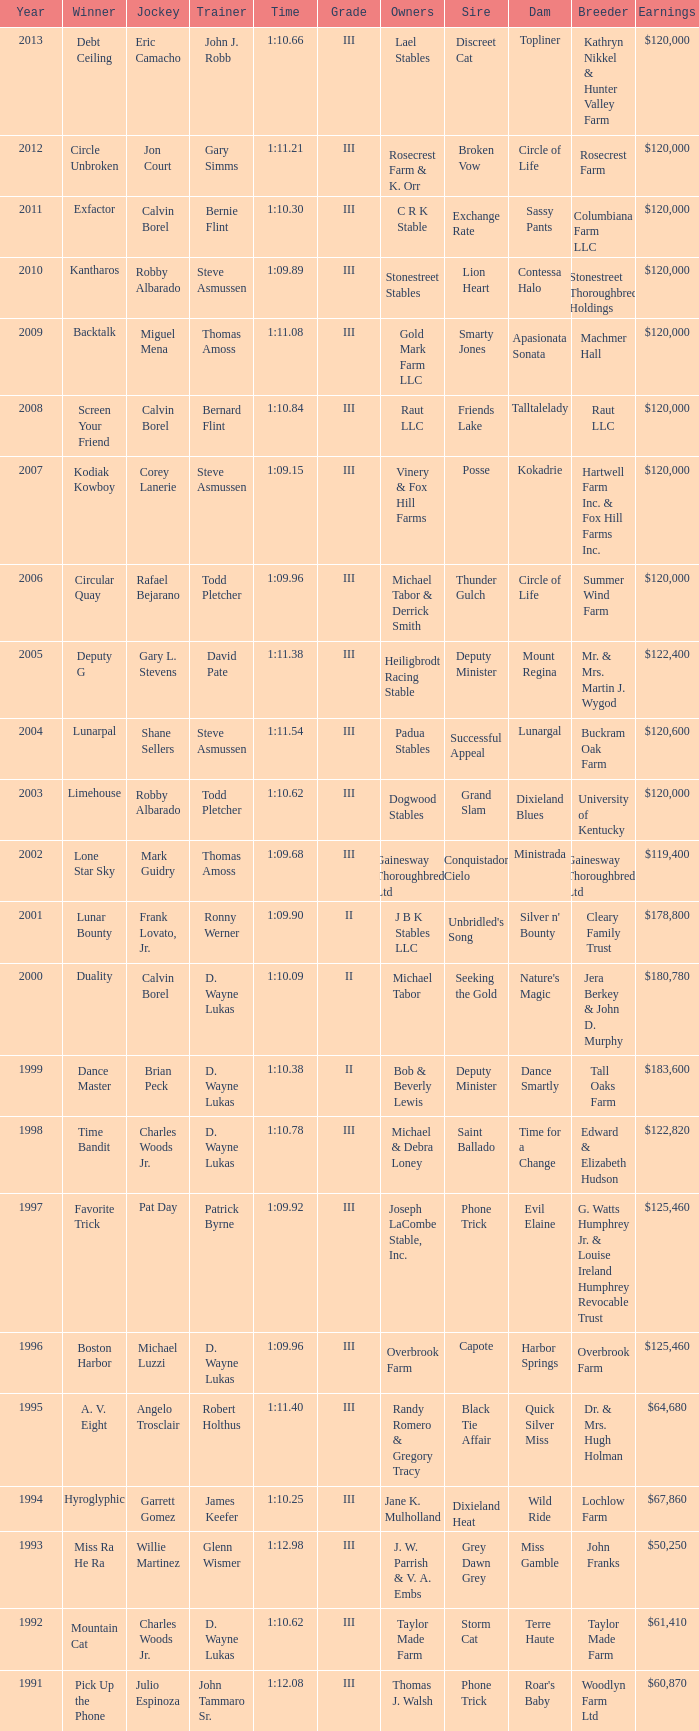Which trainer won the hyroglyphic in a year that was before 2010? James Keefer. Give me the full table as a dictionary. {'header': ['Year', 'Winner', 'Jockey', 'Trainer', 'Time', 'Grade', 'Owners', 'Sire', 'Dam', 'Breeder', 'Earnings'], 'rows': [['2013', 'Debt Ceiling', 'Eric Camacho', 'John J. Robb', '1:10.66', 'III', 'Lael Stables', 'Discreet Cat', 'Topliner', 'Kathryn Nikkel & Hunter Valley Farm', '$120,000'], ['2012', 'Circle Unbroken', 'Jon Court', 'Gary Simms', '1:11.21', 'III', 'Rosecrest Farm & K. Orr', 'Broken Vow', 'Circle of Life', 'Rosecrest Farm', '$120,000'], ['2011', 'Exfactor', 'Calvin Borel', 'Bernie Flint', '1:10.30', 'III', 'C R K Stable', 'Exchange Rate', 'Sassy Pants', 'Columbiana Farm LLC', '$120,000'], ['2010', 'Kantharos', 'Robby Albarado', 'Steve Asmussen', '1:09.89', 'III', 'Stonestreet Stables', 'Lion Heart', 'Contessa Halo', 'Stonestreet Thoroughbred Holdings', '$120,000'], ['2009', 'Backtalk', 'Miguel Mena', 'Thomas Amoss', '1:11.08', 'III', 'Gold Mark Farm LLC', 'Smarty Jones', 'Apasionata Sonata', 'Machmer Hall', '$120,000'], ['2008', 'Screen Your Friend', 'Calvin Borel', 'Bernard Flint', '1:10.84', 'III', 'Raut LLC', 'Friends Lake', 'Talltalelady', 'Raut LLC', '$120,000'], ['2007', 'Kodiak Kowboy', 'Corey Lanerie', 'Steve Asmussen', '1:09.15', 'III', 'Vinery & Fox Hill Farms', 'Posse', 'Kokadrie', 'Hartwell Farm Inc. & Fox Hill Farms Inc.', '$120,000'], ['2006', 'Circular Quay', 'Rafael Bejarano', 'Todd Pletcher', '1:09.96', 'III', 'Michael Tabor & Derrick Smith', 'Thunder Gulch', 'Circle of Life', 'Summer Wind Farm', '$120,000'], ['2005', 'Deputy G', 'Gary L. Stevens', 'David Pate', '1:11.38', 'III', 'Heiligbrodt Racing Stable', 'Deputy Minister', 'Mount Regina', 'Mr. & Mrs. Martin J. Wygod', '$122,400'], ['2004', 'Lunarpal', 'Shane Sellers', 'Steve Asmussen', '1:11.54', 'III', 'Padua Stables', 'Successful Appeal', 'Lunargal', 'Buckram Oak Farm', '$120,600'], ['2003', 'Limehouse', 'Robby Albarado', 'Todd Pletcher', '1:10.62', 'III', 'Dogwood Stables', 'Grand Slam', 'Dixieland Blues', 'University of Kentucky', '$120,000'], ['2002', 'Lone Star Sky', 'Mark Guidry', 'Thomas Amoss', '1:09.68', 'III', 'Gainesway Thoroughbreds Ltd', 'Conquistador Cielo', 'Ministrada', 'Gainesway Thoroughbreds Ltd', '$119,400'], ['2001', 'Lunar Bounty', 'Frank Lovato, Jr.', 'Ronny Werner', '1:09.90', 'II', 'J B K Stables LLC', "Unbridled's Song", "Silver n' Bounty", 'Cleary Family Trust', '$178,800'], ['2000', 'Duality', 'Calvin Borel', 'D. Wayne Lukas', '1:10.09', 'II', 'Michael Tabor', 'Seeking the Gold', "Nature's Magic", 'Jera Berkey & John D. Murphy', '$180,780'], ['1999', 'Dance Master', 'Brian Peck', 'D. Wayne Lukas', '1:10.38', 'II', 'Bob & Beverly Lewis', 'Deputy Minister', 'Dance Smartly', 'Tall Oaks Farm', '$183,600'], ['1998', 'Time Bandit', 'Charles Woods Jr.', 'D. Wayne Lukas', '1:10.78', 'III', 'Michael & Debra Loney', 'Saint Ballado', 'Time for a Change', 'Edward & Elizabeth Hudson', '$122,820'], ['1997', 'Favorite Trick', 'Pat Day', 'Patrick Byrne', '1:09.92', 'III', 'Joseph LaCombe Stable, Inc.', 'Phone Trick', 'Evil Elaine', 'G. Watts Humphrey Jr. & Louise Ireland Humphrey Revocable Trust', '$125,460'], ['1996', 'Boston Harbor', 'Michael Luzzi', 'D. Wayne Lukas', '1:09.96', 'III', 'Overbrook Farm', 'Capote', 'Harbor Springs', 'Overbrook Farm', '$125,460'], ['1995', 'A. V. Eight', 'Angelo Trosclair', 'Robert Holthus', '1:11.40', 'III', 'Randy Romero & Gregory Tracy', 'Black Tie Affair', 'Quick Silver Miss', 'Dr. & Mrs. Hugh Holman', '$64,680'], ['1994', 'Hyroglyphic', 'Garrett Gomez', 'James Keefer', '1:10.25', 'III', 'Jane K. Mulholland', 'Dixieland Heat', 'Wild Ride', 'Lochlow Farm', '$67,860'], ['1993', 'Miss Ra He Ra', 'Willie Martinez', 'Glenn Wismer', '1:12.98', 'III', 'J. W. Parrish & V. A. Embs', 'Grey Dawn Grey', 'Miss Gamble', 'John Franks', '$50,250'], ['1992', 'Mountain Cat', 'Charles Woods Jr.', 'D. Wayne Lukas', '1:10.62', 'III', 'Taylor Made Farm', 'Storm Cat', 'Terre Haute', 'Taylor Made Farm', '$61,410'], ['1991', 'Pick Up the Phone', 'Julio Espinoza', 'John Tammaro Sr.', '1:12.08', 'III', 'Thomas J. Walsh', 'Phone Trick', "Roar's Baby", 'Woodlyn Farm Ltd', '$60,870']]} 